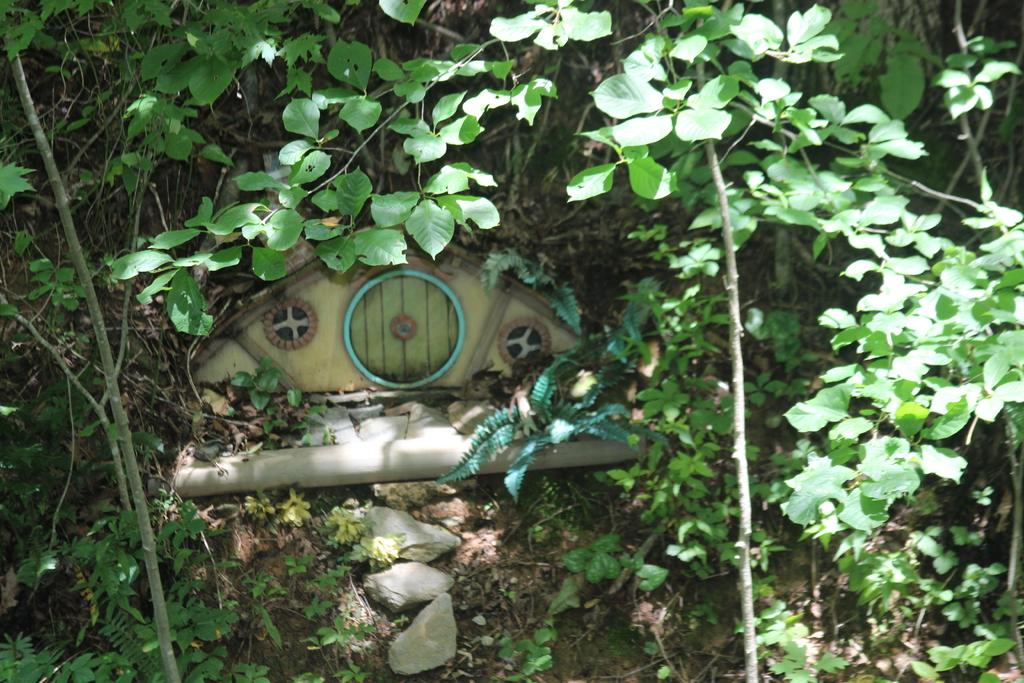What type of natural elements can be seen in the image? There are trees in the image. What type of man-made object is present in the image? There is a toy house in the image. What type of inanimate objects can be seen on the ground in the image? There are stones in the image. Can you tell me how many arguments are taking place in the image? There are no arguments present in the image. What type of garden can be seen in the image? There is no garden present in the image. 